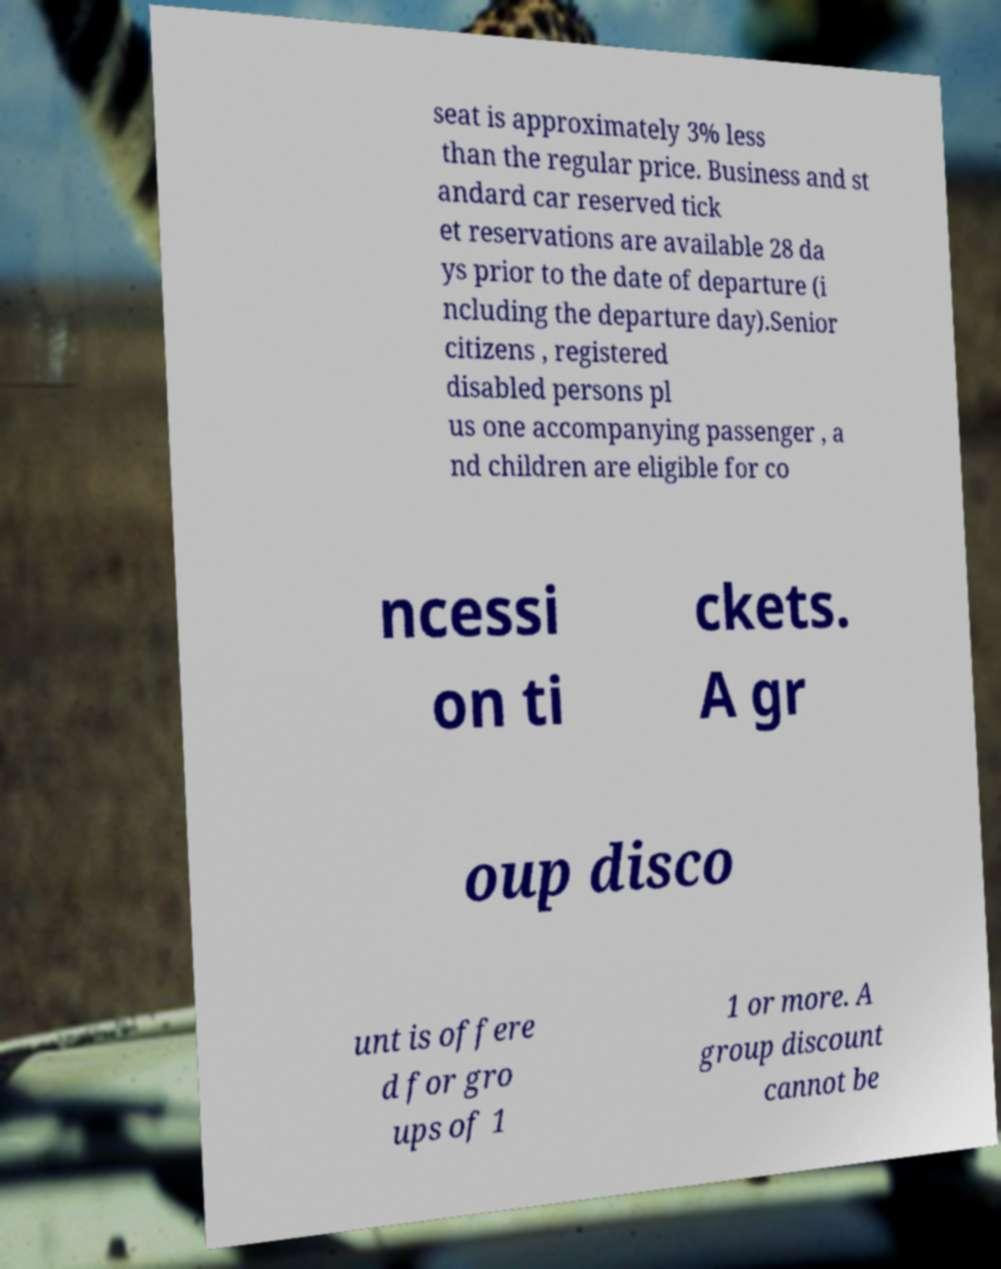Could you assist in decoding the text presented in this image and type it out clearly? seat is approximately 3% less than the regular price. Business and st andard car reserved tick et reservations are available 28 da ys prior to the date of departure (i ncluding the departure day).Senior citizens , registered disabled persons pl us one accompanying passenger , a nd children are eligible for co ncessi on ti ckets. A gr oup disco unt is offere d for gro ups of 1 1 or more. A group discount cannot be 